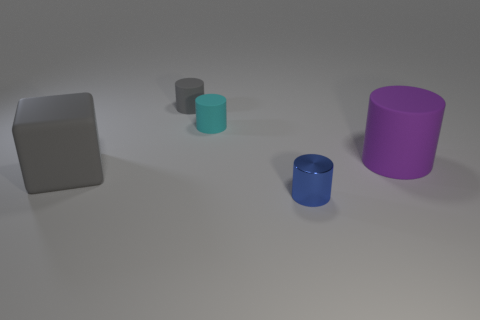Add 5 tiny cyan shiny spheres. How many objects exist? 10 Subtract all blocks. How many objects are left? 4 Subtract all large purple cylinders. Subtract all tiny green matte balls. How many objects are left? 4 Add 5 big blocks. How many big blocks are left? 6 Add 3 cyan matte cubes. How many cyan matte cubes exist? 3 Subtract 1 gray cubes. How many objects are left? 4 